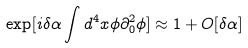<formula> <loc_0><loc_0><loc_500><loc_500>\exp [ i \delta \alpha \int d ^ { 4 } x \phi \partial ^ { 2 } _ { 0 } \phi ] \approx 1 + O [ \delta \alpha ]</formula> 